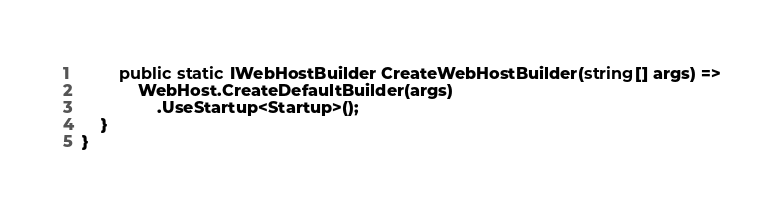Convert code to text. <code><loc_0><loc_0><loc_500><loc_500><_C#_>
        public static IWebHostBuilder CreateWebHostBuilder(string[] args) =>
            WebHost.CreateDefaultBuilder(args)
                .UseStartup<Startup>();
    }
}
</code> 